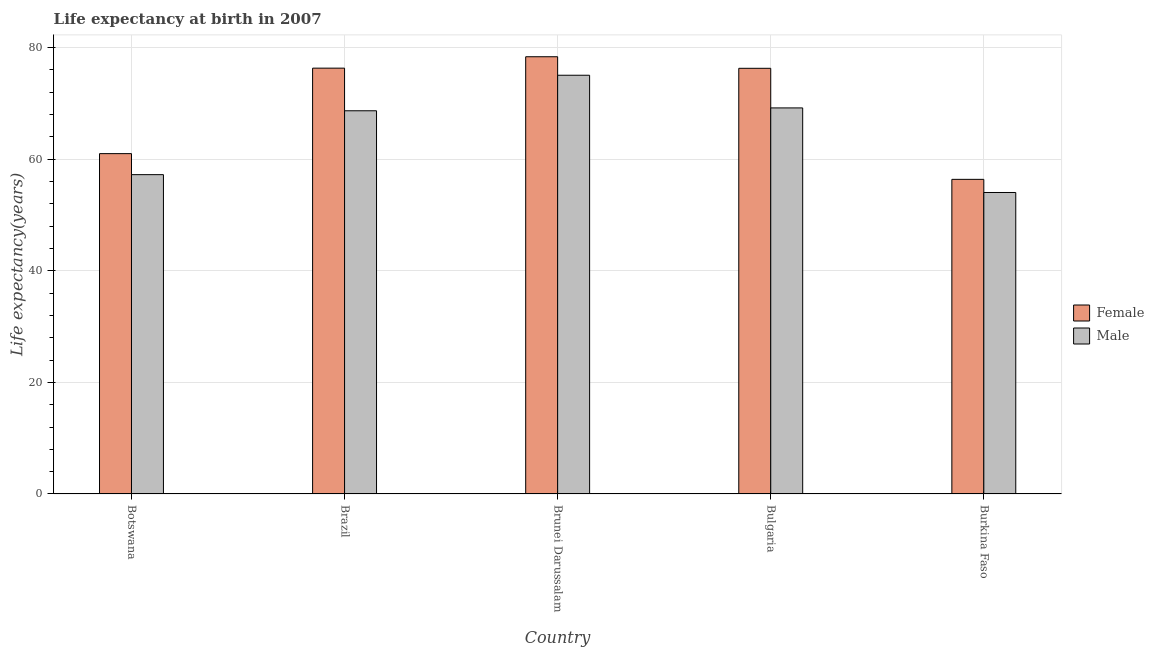How many different coloured bars are there?
Keep it short and to the point. 2. How many groups of bars are there?
Keep it short and to the point. 5. Are the number of bars per tick equal to the number of legend labels?
Ensure brevity in your answer.  Yes. What is the label of the 3rd group of bars from the left?
Ensure brevity in your answer.  Brunei Darussalam. In how many cases, is the number of bars for a given country not equal to the number of legend labels?
Provide a succinct answer. 0. What is the life expectancy(male) in Botswana?
Give a very brief answer. 57.24. Across all countries, what is the maximum life expectancy(female)?
Ensure brevity in your answer.  78.37. Across all countries, what is the minimum life expectancy(female)?
Your answer should be compact. 56.39. In which country was the life expectancy(male) maximum?
Your response must be concise. Brunei Darussalam. In which country was the life expectancy(female) minimum?
Your answer should be compact. Burkina Faso. What is the total life expectancy(male) in the graph?
Make the answer very short. 324.22. What is the difference between the life expectancy(female) in Botswana and that in Brunei Darussalam?
Offer a very short reply. -17.37. What is the difference between the life expectancy(female) in Bulgaria and the life expectancy(male) in Brazil?
Your answer should be very brief. 7.61. What is the average life expectancy(female) per country?
Your answer should be compact. 69.68. What is the difference between the life expectancy(female) and life expectancy(male) in Burkina Faso?
Offer a terse response. 2.35. In how many countries, is the life expectancy(male) greater than 28 years?
Offer a very short reply. 5. What is the ratio of the life expectancy(male) in Brazil to that in Brunei Darussalam?
Provide a short and direct response. 0.92. Is the life expectancy(male) in Brunei Darussalam less than that in Bulgaria?
Give a very brief answer. No. What is the difference between the highest and the second highest life expectancy(female)?
Provide a short and direct response. 2.05. What is the difference between the highest and the lowest life expectancy(male)?
Offer a very short reply. 21.02. In how many countries, is the life expectancy(male) greater than the average life expectancy(male) taken over all countries?
Provide a succinct answer. 3. What does the 2nd bar from the left in Brazil represents?
Your answer should be very brief. Male. What does the 1st bar from the right in Burkina Faso represents?
Ensure brevity in your answer.  Male. How many bars are there?
Your answer should be very brief. 10. Are all the bars in the graph horizontal?
Your answer should be very brief. No. How many countries are there in the graph?
Your answer should be compact. 5. Are the values on the major ticks of Y-axis written in scientific E-notation?
Ensure brevity in your answer.  No. Does the graph contain any zero values?
Make the answer very short. No. Does the graph contain grids?
Ensure brevity in your answer.  Yes. What is the title of the graph?
Your response must be concise. Life expectancy at birth in 2007. Does "Age 65(female)" appear as one of the legend labels in the graph?
Your answer should be compact. No. What is the label or title of the Y-axis?
Your answer should be compact. Life expectancy(years). What is the Life expectancy(years) in Female in Botswana?
Your answer should be very brief. 61. What is the Life expectancy(years) of Male in Botswana?
Ensure brevity in your answer.  57.24. What is the Life expectancy(years) in Female in Brazil?
Make the answer very short. 76.33. What is the Life expectancy(years) of Male in Brazil?
Your answer should be compact. 68.69. What is the Life expectancy(years) in Female in Brunei Darussalam?
Your answer should be very brief. 78.37. What is the Life expectancy(years) in Male in Brunei Darussalam?
Provide a short and direct response. 75.06. What is the Life expectancy(years) of Female in Bulgaria?
Your answer should be compact. 76.3. What is the Life expectancy(years) of Male in Bulgaria?
Ensure brevity in your answer.  69.2. What is the Life expectancy(years) of Female in Burkina Faso?
Provide a succinct answer. 56.39. What is the Life expectancy(years) of Male in Burkina Faso?
Your answer should be very brief. 54.04. Across all countries, what is the maximum Life expectancy(years) of Female?
Provide a short and direct response. 78.37. Across all countries, what is the maximum Life expectancy(years) of Male?
Your answer should be very brief. 75.06. Across all countries, what is the minimum Life expectancy(years) in Female?
Offer a very short reply. 56.39. Across all countries, what is the minimum Life expectancy(years) in Male?
Offer a very short reply. 54.04. What is the total Life expectancy(years) of Female in the graph?
Offer a terse response. 348.4. What is the total Life expectancy(years) of Male in the graph?
Offer a very short reply. 324.22. What is the difference between the Life expectancy(years) of Female in Botswana and that in Brazil?
Provide a succinct answer. -15.32. What is the difference between the Life expectancy(years) in Male in Botswana and that in Brazil?
Offer a very short reply. -11.45. What is the difference between the Life expectancy(years) in Female in Botswana and that in Brunei Darussalam?
Ensure brevity in your answer.  -17.37. What is the difference between the Life expectancy(years) in Male in Botswana and that in Brunei Darussalam?
Give a very brief answer. -17.82. What is the difference between the Life expectancy(years) of Female in Botswana and that in Bulgaria?
Offer a terse response. -15.3. What is the difference between the Life expectancy(years) in Male in Botswana and that in Bulgaria?
Provide a succinct answer. -11.96. What is the difference between the Life expectancy(years) of Female in Botswana and that in Burkina Faso?
Provide a short and direct response. 4.61. What is the difference between the Life expectancy(years) of Male in Botswana and that in Burkina Faso?
Your answer should be compact. 3.2. What is the difference between the Life expectancy(years) in Female in Brazil and that in Brunei Darussalam?
Ensure brevity in your answer.  -2.05. What is the difference between the Life expectancy(years) of Male in Brazil and that in Brunei Darussalam?
Provide a short and direct response. -6.37. What is the difference between the Life expectancy(years) of Female in Brazil and that in Bulgaria?
Your response must be concise. 0.03. What is the difference between the Life expectancy(years) of Male in Brazil and that in Bulgaria?
Your answer should be compact. -0.51. What is the difference between the Life expectancy(years) in Female in Brazil and that in Burkina Faso?
Your answer should be very brief. 19.93. What is the difference between the Life expectancy(years) in Male in Brazil and that in Burkina Faso?
Offer a terse response. 14.65. What is the difference between the Life expectancy(years) of Female in Brunei Darussalam and that in Bulgaria?
Provide a short and direct response. 2.07. What is the difference between the Life expectancy(years) of Male in Brunei Darussalam and that in Bulgaria?
Provide a succinct answer. 5.86. What is the difference between the Life expectancy(years) of Female in Brunei Darussalam and that in Burkina Faso?
Offer a terse response. 21.98. What is the difference between the Life expectancy(years) of Male in Brunei Darussalam and that in Burkina Faso?
Give a very brief answer. 21.02. What is the difference between the Life expectancy(years) in Female in Bulgaria and that in Burkina Faso?
Give a very brief answer. 19.91. What is the difference between the Life expectancy(years) of Male in Bulgaria and that in Burkina Faso?
Give a very brief answer. 15.16. What is the difference between the Life expectancy(years) of Female in Botswana and the Life expectancy(years) of Male in Brazil?
Give a very brief answer. -7.68. What is the difference between the Life expectancy(years) in Female in Botswana and the Life expectancy(years) in Male in Brunei Darussalam?
Your answer should be compact. -14.05. What is the difference between the Life expectancy(years) of Female in Botswana and the Life expectancy(years) of Male in Bulgaria?
Provide a short and direct response. -8.2. What is the difference between the Life expectancy(years) of Female in Botswana and the Life expectancy(years) of Male in Burkina Faso?
Provide a short and direct response. 6.96. What is the difference between the Life expectancy(years) in Female in Brazil and the Life expectancy(years) in Male in Brunei Darussalam?
Make the answer very short. 1.27. What is the difference between the Life expectancy(years) of Female in Brazil and the Life expectancy(years) of Male in Bulgaria?
Your answer should be very brief. 7.13. What is the difference between the Life expectancy(years) of Female in Brazil and the Life expectancy(years) of Male in Burkina Faso?
Your answer should be very brief. 22.29. What is the difference between the Life expectancy(years) in Female in Brunei Darussalam and the Life expectancy(years) in Male in Bulgaria?
Make the answer very short. 9.17. What is the difference between the Life expectancy(years) of Female in Brunei Darussalam and the Life expectancy(years) of Male in Burkina Faso?
Make the answer very short. 24.33. What is the difference between the Life expectancy(years) in Female in Bulgaria and the Life expectancy(years) in Male in Burkina Faso?
Ensure brevity in your answer.  22.26. What is the average Life expectancy(years) of Female per country?
Your response must be concise. 69.68. What is the average Life expectancy(years) in Male per country?
Provide a succinct answer. 64.84. What is the difference between the Life expectancy(years) in Female and Life expectancy(years) in Male in Botswana?
Offer a very short reply. 3.77. What is the difference between the Life expectancy(years) in Female and Life expectancy(years) in Male in Brazil?
Keep it short and to the point. 7.64. What is the difference between the Life expectancy(years) of Female and Life expectancy(years) of Male in Brunei Darussalam?
Your response must be concise. 3.32. What is the difference between the Life expectancy(years) of Female and Life expectancy(years) of Male in Burkina Faso?
Offer a terse response. 2.35. What is the ratio of the Life expectancy(years) of Female in Botswana to that in Brazil?
Keep it short and to the point. 0.8. What is the ratio of the Life expectancy(years) of Female in Botswana to that in Brunei Darussalam?
Provide a succinct answer. 0.78. What is the ratio of the Life expectancy(years) of Male in Botswana to that in Brunei Darussalam?
Offer a terse response. 0.76. What is the ratio of the Life expectancy(years) in Female in Botswana to that in Bulgaria?
Offer a very short reply. 0.8. What is the ratio of the Life expectancy(years) in Male in Botswana to that in Bulgaria?
Provide a succinct answer. 0.83. What is the ratio of the Life expectancy(years) of Female in Botswana to that in Burkina Faso?
Your response must be concise. 1.08. What is the ratio of the Life expectancy(years) in Male in Botswana to that in Burkina Faso?
Make the answer very short. 1.06. What is the ratio of the Life expectancy(years) of Female in Brazil to that in Brunei Darussalam?
Ensure brevity in your answer.  0.97. What is the ratio of the Life expectancy(years) in Male in Brazil to that in Brunei Darussalam?
Ensure brevity in your answer.  0.92. What is the ratio of the Life expectancy(years) of Female in Brazil to that in Burkina Faso?
Provide a succinct answer. 1.35. What is the ratio of the Life expectancy(years) in Male in Brazil to that in Burkina Faso?
Give a very brief answer. 1.27. What is the ratio of the Life expectancy(years) in Female in Brunei Darussalam to that in Bulgaria?
Give a very brief answer. 1.03. What is the ratio of the Life expectancy(years) of Male in Brunei Darussalam to that in Bulgaria?
Your response must be concise. 1.08. What is the ratio of the Life expectancy(years) in Female in Brunei Darussalam to that in Burkina Faso?
Your answer should be compact. 1.39. What is the ratio of the Life expectancy(years) of Male in Brunei Darussalam to that in Burkina Faso?
Ensure brevity in your answer.  1.39. What is the ratio of the Life expectancy(years) in Female in Bulgaria to that in Burkina Faso?
Provide a short and direct response. 1.35. What is the ratio of the Life expectancy(years) of Male in Bulgaria to that in Burkina Faso?
Your response must be concise. 1.28. What is the difference between the highest and the second highest Life expectancy(years) of Female?
Ensure brevity in your answer.  2.05. What is the difference between the highest and the second highest Life expectancy(years) in Male?
Provide a succinct answer. 5.86. What is the difference between the highest and the lowest Life expectancy(years) in Female?
Provide a short and direct response. 21.98. What is the difference between the highest and the lowest Life expectancy(years) in Male?
Ensure brevity in your answer.  21.02. 